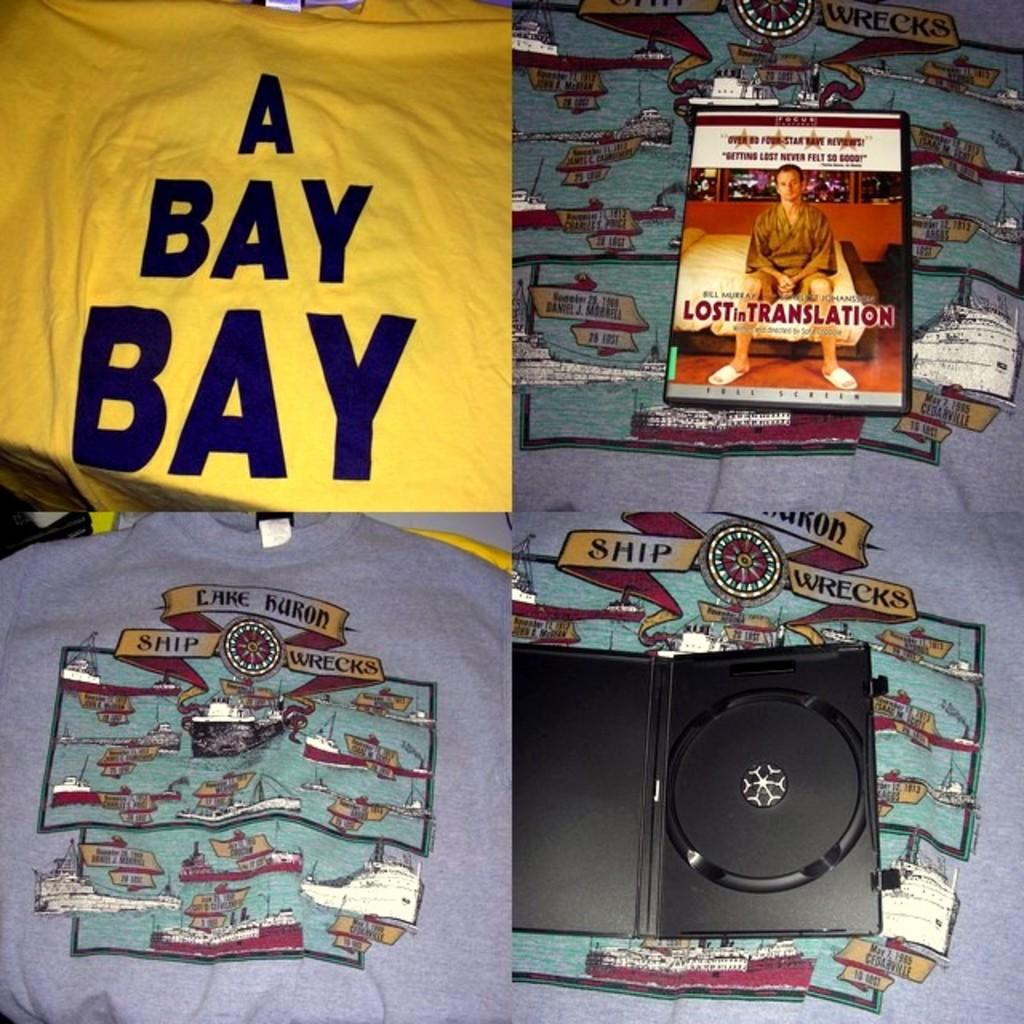<image>
Provide a brief description of the given image. The blue t-shirts show Cake Kuron Ship Wrecks. 